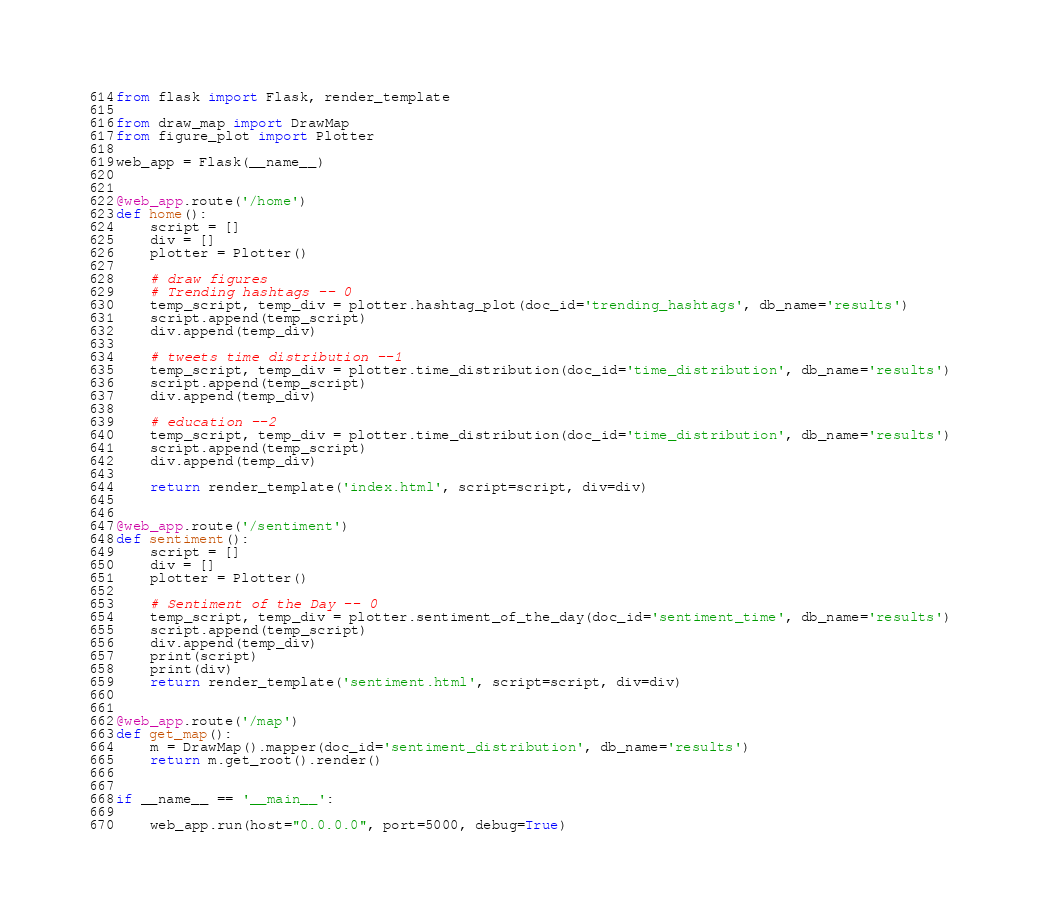<code> <loc_0><loc_0><loc_500><loc_500><_Python_>from flask import Flask, render_template

from draw_map import DrawMap
from figure_plot import Plotter

web_app = Flask(__name__)


@web_app.route('/home')
def home():
    script = []
    div = []
    plotter = Plotter()

    # draw figures
    # Trending hashtags -- 0
    temp_script, temp_div = plotter.hashtag_plot(doc_id='trending_hashtags', db_name='results')
    script.append(temp_script)
    div.append(temp_div)

    # tweets time distribution --1
    temp_script, temp_div = plotter.time_distribution(doc_id='time_distribution', db_name='results')
    script.append(temp_script)
    div.append(temp_div)

    # education --2
    temp_script, temp_div = plotter.time_distribution(doc_id='time_distribution', db_name='results')
    script.append(temp_script)
    div.append(temp_div)

    return render_template('index.html', script=script, div=div)


@web_app.route('/sentiment')
def sentiment():
    script = []
    div = []
    plotter = Plotter()

    # Sentiment of the Day -- 0
    temp_script, temp_div = plotter.sentiment_of_the_day(doc_id='sentiment_time', db_name='results')
    script.append(temp_script)
    div.append(temp_div)
    print(script)
    print(div)
    return render_template('sentiment.html', script=script, div=div)


@web_app.route('/map')
def get_map():
    m = DrawMap().mapper(doc_id='sentiment_distribution', db_name='results')
    return m.get_root().render()


if __name__ == '__main__':

    web_app.run(host="0.0.0.0", port=5000, debug=True)
</code> 